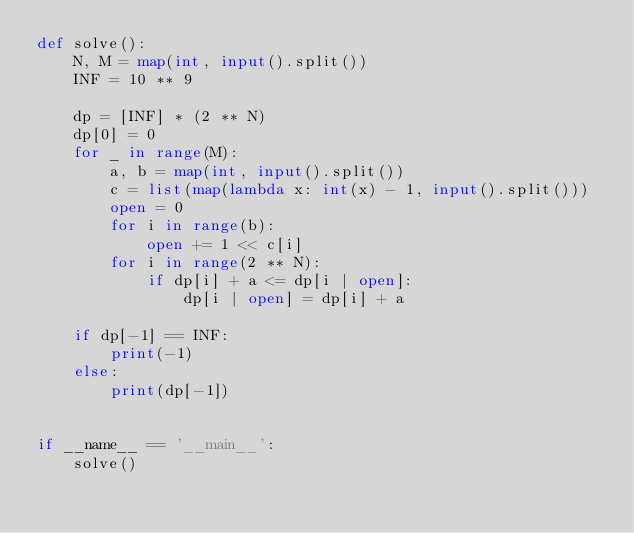<code> <loc_0><loc_0><loc_500><loc_500><_Python_>def solve():
    N, M = map(int, input().split())
    INF = 10 ** 9
    
    dp = [INF] * (2 ** N)
    dp[0] = 0
    for _ in range(M):
        a, b = map(int, input().split())
        c = list(map(lambda x: int(x) - 1, input().split()))
        open = 0
        for i in range(b):
            open += 1 << c[i]
        for i in range(2 ** N):
            if dp[i] + a <= dp[i | open]:
                dp[i | open] = dp[i] + a
    
    if dp[-1] == INF:
        print(-1)
    else:
        print(dp[-1])


if __name__ == '__main__':
    solve()
</code> 